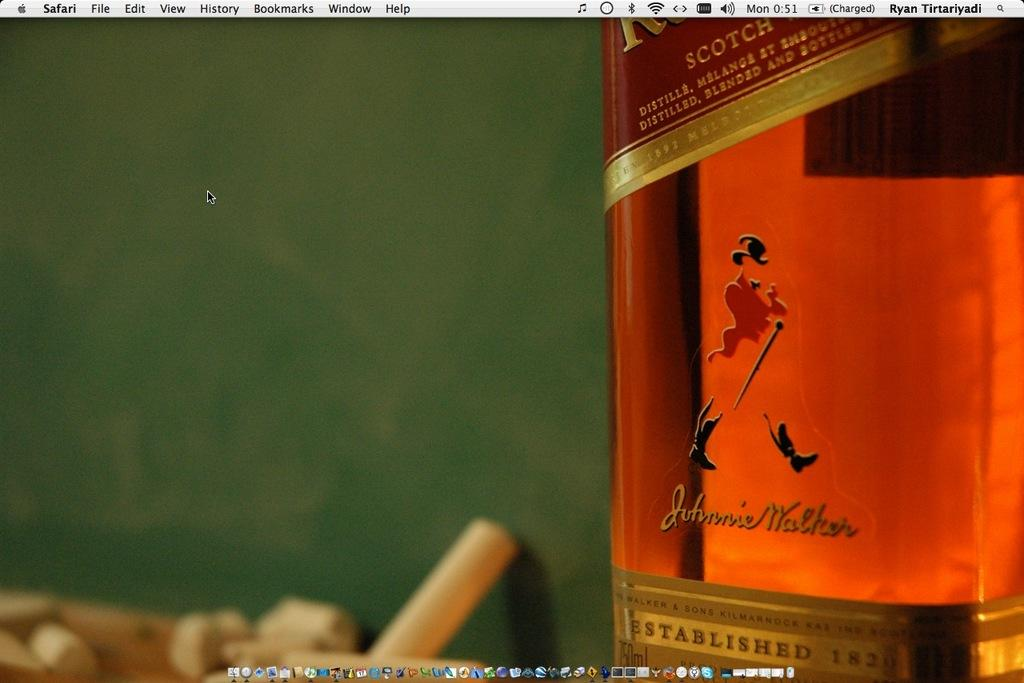<image>
Write a terse but informative summary of the picture. A bottle of Johnny Walker is sitting on the desktop screen of a computer 